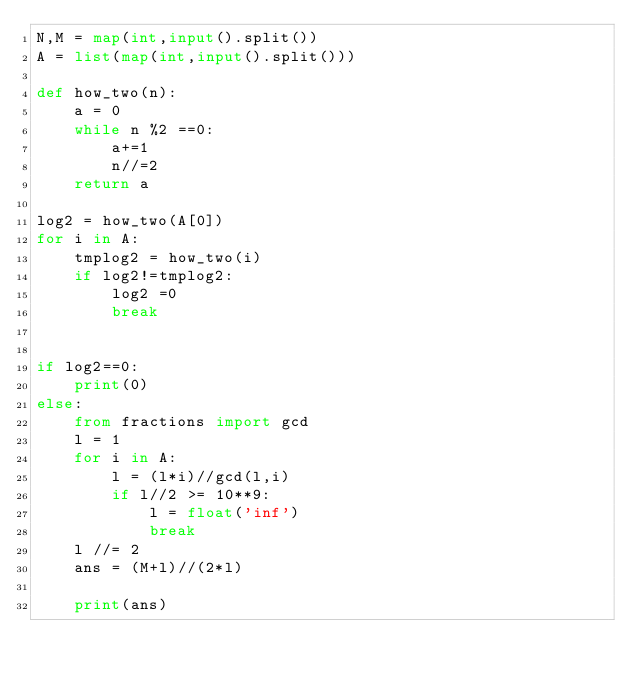Convert code to text. <code><loc_0><loc_0><loc_500><loc_500><_Python_>N,M = map(int,input().split())
A = list(map(int,input().split()))
 
def how_two(n):
    a = 0
    while n %2 ==0:
        a+=1
        n//=2
    return a
 
log2 = how_two(A[0])
for i in A:
    tmplog2 = how_two(i)
    if log2!=tmplog2:
        log2 =0
        break
        
        
if log2==0:
    print(0)
else:
    from fractions import gcd
    l = 1
    for i in A:
        l = (l*i)//gcd(l,i)
        if l//2 >= 10**9:
            l = float('inf')
            break
    l //= 2
    ans = (M+l)//(2*l)
    
    print(ans)</code> 